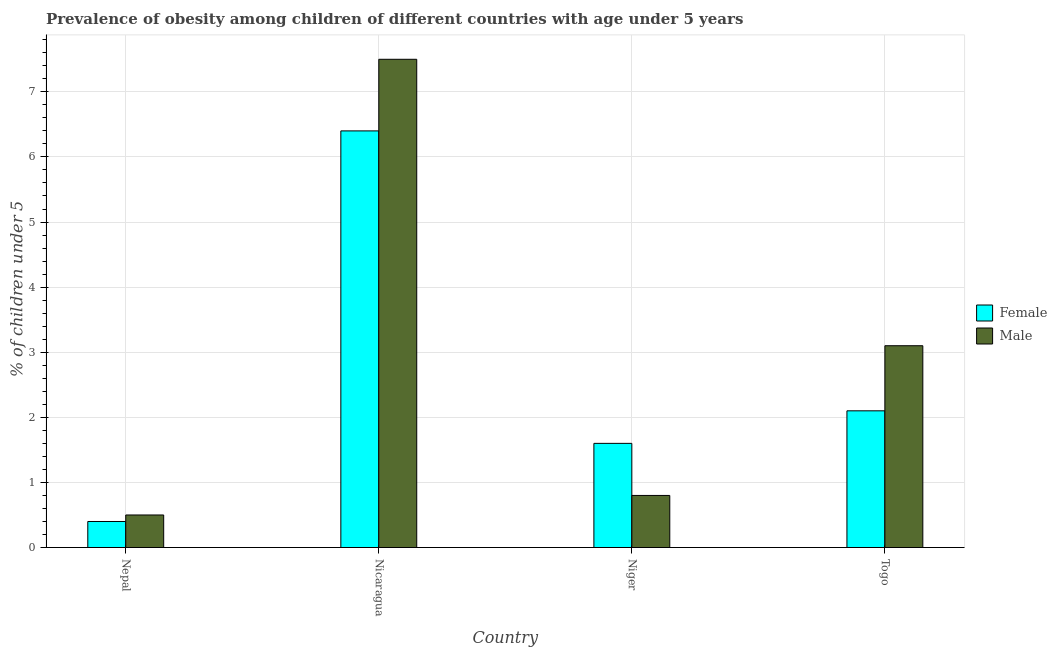How many different coloured bars are there?
Ensure brevity in your answer.  2. Are the number of bars per tick equal to the number of legend labels?
Your answer should be compact. Yes. How many bars are there on the 4th tick from the right?
Offer a very short reply. 2. What is the label of the 1st group of bars from the left?
Provide a short and direct response. Nepal. In how many cases, is the number of bars for a given country not equal to the number of legend labels?
Offer a terse response. 0. What is the percentage of obese female children in Togo?
Offer a very short reply. 2.1. Across all countries, what is the maximum percentage of obese female children?
Ensure brevity in your answer.  6.4. Across all countries, what is the minimum percentage of obese male children?
Make the answer very short. 0.5. In which country was the percentage of obese female children maximum?
Keep it short and to the point. Nicaragua. In which country was the percentage of obese male children minimum?
Give a very brief answer. Nepal. What is the total percentage of obese female children in the graph?
Your answer should be compact. 10.5. What is the difference between the percentage of obese male children in Nicaragua and that in Niger?
Your answer should be compact. 6.7. What is the difference between the percentage of obese female children in Niger and the percentage of obese male children in Togo?
Provide a short and direct response. -1.5. What is the average percentage of obese female children per country?
Your answer should be very brief. 2.63. What is the difference between the percentage of obese female children and percentage of obese male children in Niger?
Your answer should be very brief. 0.8. In how many countries, is the percentage of obese female children greater than 2 %?
Make the answer very short. 2. What is the ratio of the percentage of obese male children in Nepal to that in Niger?
Keep it short and to the point. 0.62. What is the difference between the highest and the second highest percentage of obese female children?
Provide a short and direct response. 4.3. What is the difference between the highest and the lowest percentage of obese female children?
Give a very brief answer. 6. In how many countries, is the percentage of obese male children greater than the average percentage of obese male children taken over all countries?
Your answer should be compact. 2. Is the sum of the percentage of obese female children in Nepal and Nicaragua greater than the maximum percentage of obese male children across all countries?
Your response must be concise. No. What does the 1st bar from the right in Nepal represents?
Give a very brief answer. Male. How many bars are there?
Ensure brevity in your answer.  8. Are all the bars in the graph horizontal?
Ensure brevity in your answer.  No. How many countries are there in the graph?
Keep it short and to the point. 4. Does the graph contain grids?
Keep it short and to the point. Yes. Where does the legend appear in the graph?
Give a very brief answer. Center right. How many legend labels are there?
Ensure brevity in your answer.  2. How are the legend labels stacked?
Offer a very short reply. Vertical. What is the title of the graph?
Your response must be concise. Prevalence of obesity among children of different countries with age under 5 years. What is the label or title of the Y-axis?
Your response must be concise.  % of children under 5. What is the  % of children under 5 of Female in Nepal?
Provide a succinct answer. 0.4. What is the  % of children under 5 of Female in Nicaragua?
Offer a terse response. 6.4. What is the  % of children under 5 of Female in Niger?
Your answer should be compact. 1.6. What is the  % of children under 5 in Male in Niger?
Provide a succinct answer. 0.8. What is the  % of children under 5 of Female in Togo?
Your answer should be very brief. 2.1. What is the  % of children under 5 of Male in Togo?
Provide a succinct answer. 3.1. Across all countries, what is the maximum  % of children under 5 in Female?
Offer a terse response. 6.4. Across all countries, what is the maximum  % of children under 5 in Male?
Your answer should be very brief. 7.5. Across all countries, what is the minimum  % of children under 5 of Female?
Your answer should be very brief. 0.4. What is the total  % of children under 5 in Male in the graph?
Ensure brevity in your answer.  11.9. What is the difference between the  % of children under 5 of Female in Nepal and that in Nicaragua?
Give a very brief answer. -6. What is the difference between the  % of children under 5 of Male in Nepal and that in Nicaragua?
Give a very brief answer. -7. What is the difference between the  % of children under 5 in Female in Nepal and that in Niger?
Your answer should be very brief. -1.2. What is the difference between the  % of children under 5 of Male in Nepal and that in Togo?
Give a very brief answer. -2.6. What is the difference between the  % of children under 5 in Male in Nicaragua and that in Niger?
Ensure brevity in your answer.  6.7. What is the difference between the  % of children under 5 in Female in Nicaragua and that in Togo?
Ensure brevity in your answer.  4.3. What is the difference between the  % of children under 5 in Female in Niger and that in Togo?
Make the answer very short. -0.5. What is the difference between the  % of children under 5 in Female in Nepal and the  % of children under 5 in Male in Nicaragua?
Offer a very short reply. -7.1. What is the difference between the  % of children under 5 of Female in Nicaragua and the  % of children under 5 of Male in Niger?
Your answer should be very brief. 5.6. What is the difference between the  % of children under 5 of Female in Niger and the  % of children under 5 of Male in Togo?
Your answer should be compact. -1.5. What is the average  % of children under 5 in Female per country?
Provide a succinct answer. 2.62. What is the average  % of children under 5 in Male per country?
Make the answer very short. 2.98. What is the difference between the  % of children under 5 in Female and  % of children under 5 in Male in Nepal?
Your response must be concise. -0.1. What is the difference between the  % of children under 5 of Female and  % of children under 5 of Male in Nicaragua?
Your answer should be compact. -1.1. What is the difference between the  % of children under 5 in Female and  % of children under 5 in Male in Niger?
Offer a very short reply. 0.8. What is the difference between the  % of children under 5 in Female and  % of children under 5 in Male in Togo?
Provide a succinct answer. -1. What is the ratio of the  % of children under 5 of Female in Nepal to that in Nicaragua?
Provide a succinct answer. 0.06. What is the ratio of the  % of children under 5 in Male in Nepal to that in Nicaragua?
Your response must be concise. 0.07. What is the ratio of the  % of children under 5 of Female in Nepal to that in Niger?
Your answer should be very brief. 0.25. What is the ratio of the  % of children under 5 in Female in Nepal to that in Togo?
Keep it short and to the point. 0.19. What is the ratio of the  % of children under 5 of Male in Nepal to that in Togo?
Offer a terse response. 0.16. What is the ratio of the  % of children under 5 of Female in Nicaragua to that in Niger?
Your answer should be very brief. 4. What is the ratio of the  % of children under 5 of Male in Nicaragua to that in Niger?
Provide a short and direct response. 9.38. What is the ratio of the  % of children under 5 in Female in Nicaragua to that in Togo?
Ensure brevity in your answer.  3.05. What is the ratio of the  % of children under 5 of Male in Nicaragua to that in Togo?
Your response must be concise. 2.42. What is the ratio of the  % of children under 5 in Female in Niger to that in Togo?
Provide a succinct answer. 0.76. What is the ratio of the  % of children under 5 of Male in Niger to that in Togo?
Offer a terse response. 0.26. What is the difference between the highest and the lowest  % of children under 5 of Female?
Offer a terse response. 6. What is the difference between the highest and the lowest  % of children under 5 in Male?
Your answer should be very brief. 7. 